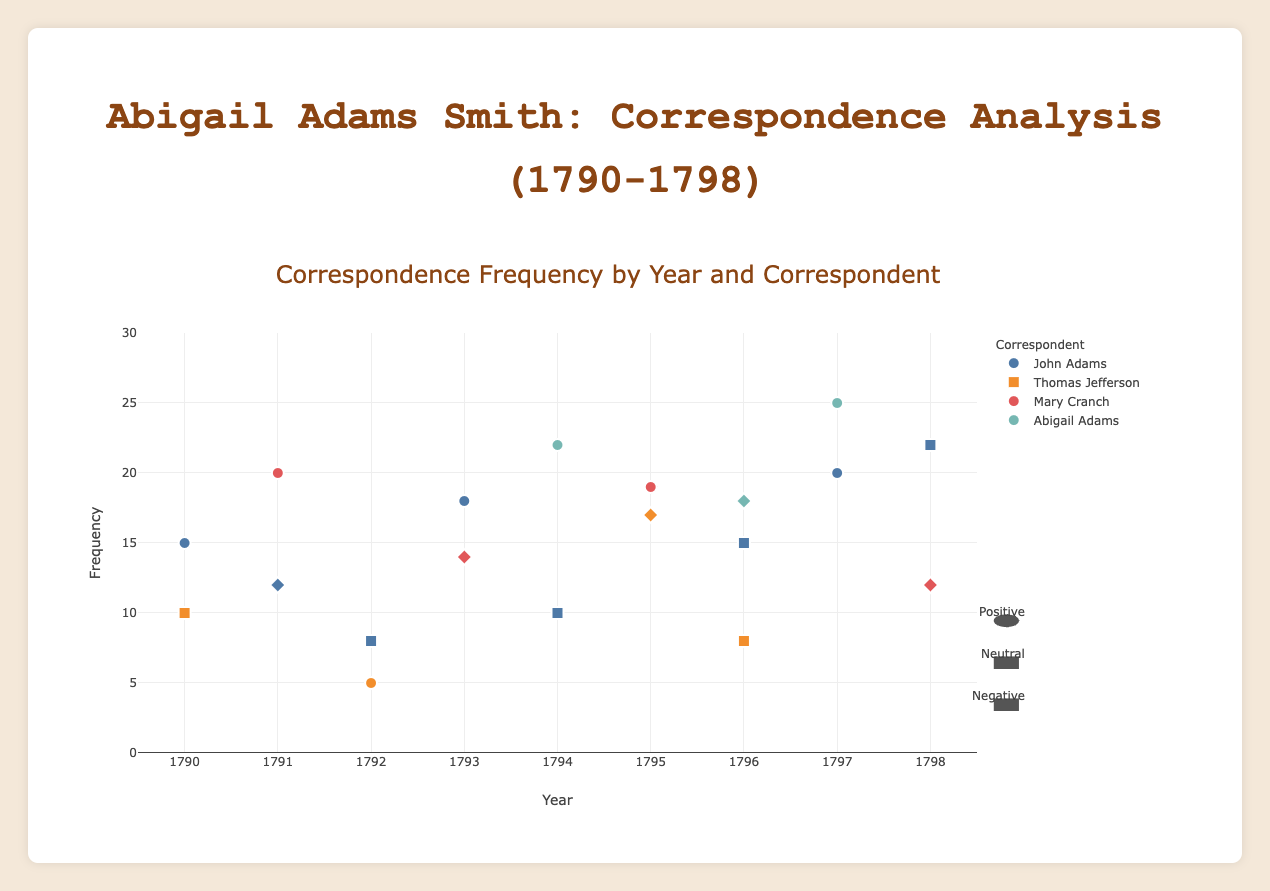What is the title of the plot? The title is displayed at the top of the plot and is "Correspondence Frequency by Year and Correspondent"
Answer: Correspondence Frequency by Year and Correspondent Which correspondent had the highest frequency in 1797? By looking at the data points for 1797, Abigail Adams had the highest frequency with 25 correspondences
Answer: Abigail Adams What was the emotional tone of the correspondence from Thomas Jefferson in 1795? By locating the 1795 data point for Thomas Jefferson, the emotional tone is indicated by a diamond shape which corresponds to a negative tone according to the legend
Answer: Negative How many correspondents sent letters in 1790? There are data points for two correspondents in 1790, which are John Adams and Thomas Jefferson
Answer: Two What is the average frequency of correspondence for John Adams over the entire period shown? The frequencies for John Adams from 1790 to 1798 are 15, 12, 8, 18, 10, 15, 20, 22. Summing these gives 120, and there are 8 years of data, so the average is 120/8
Answer: 15 Which year had the highest combined frequency of all correspondents? By examining the data points for each year and summing them, 1797 has the highest combined frequency of 45 (John Adams with 20, Abigail Adams with 25)
Answer: 1797 Compare the emotional tones of Mary Cranch's correspondences in 1791 and 1793. In 1791, Mary Cranch's letters have a positive tone indicated by circles, while in 1793, her letters have a negative tone indicated by diamonds
Answer: Positive in 1791, Negative in 1793 What is the trend in the frequency of correspondence for Thomas Jefferson over the years? For Thomas Jefferson, the frequencies are 10 (1790), 5 (1792), 17 (1795), 8 (1796). Thus, the trend shows a decreasing frequency from 1790 to 1792, an increase in 1795, followed by a decrease in 1796
Answer: Decreasing, Increasing, Decreasing How do the shapes used in the plot represent the emotional tone? The legend indicates that circles represent positive tones, squares represent neutral tones, and diamonds represent negative tones. These shapes match the tones given for each data point
Answer: Circles: Positive, Squares: Neutral, Diamonds: Negative What is the frequency difference between John Adams's correspondences in the years 1796 and 1797? From the data, John Adams had 15 correspondences in 1796 and 20 in 1797. The difference is 20 - 15
Answer: 5 